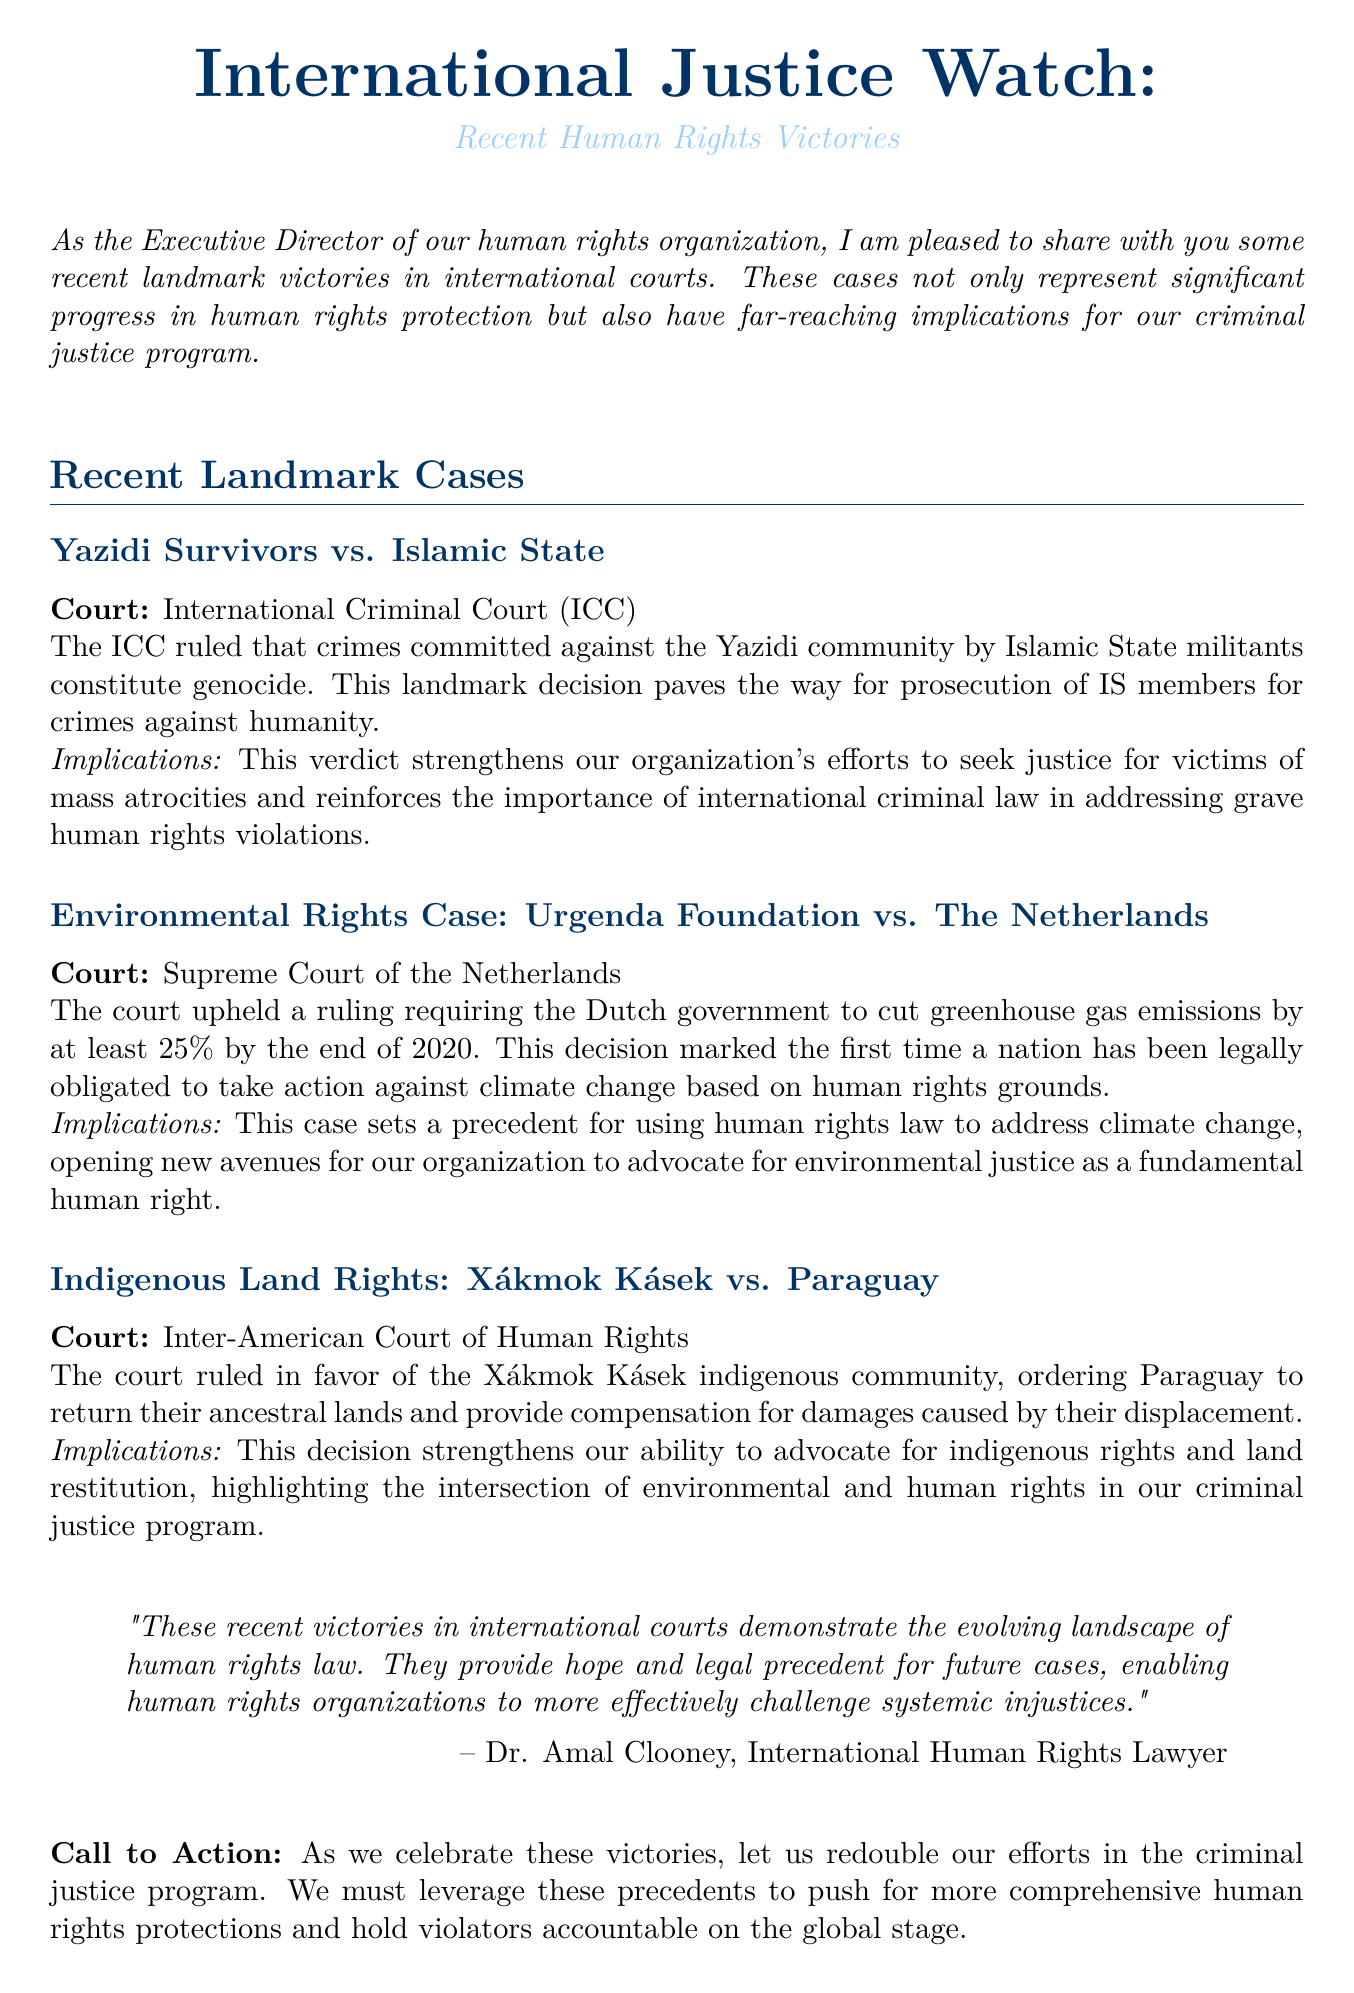What was the case name involving the Yazidi community? The document specifically mentions the case as "Yazidi Survivors vs. Islamic State."
Answer: Yazidi Survivors vs. Islamic State Which court ruled on the environmental rights case? The document states the ruling was made by the "Supreme Court of the Netherlands."
Answer: Supreme Court of the Netherlands What percentage reduction in greenhouse gas emissions was mandated by the Dutch court? The document indicates the court required a "25%" reduction by the end of 2020.
Answer: 25% Who provided an expert opinion in the newsletter? The document names "Dr. Amal Clooney" as the expert providing an opinion.
Answer: Dr. Amal Clooney What is the date of the upcoming International Criminal Justice Symposium? According to the document, the symposium is scheduled for "September 15-17, 2023."
Answer: September 15-17, 2023 What type of rights did the Xákmok Kásek case focus on? The document mentions that the case involves "Indigenous Land Rights."
Answer: Indigenous Land Rights What significant human rights concept was reinforced by the Yazidi Survivors case? The document states that the case reinforced the importance of "international criminal law."
Answer: international criminal law How does the Urgenda case connect human rights to environmental issues? The document mentions this case set a precedent for using human rights law to address "climate change."
Answer: climate change 